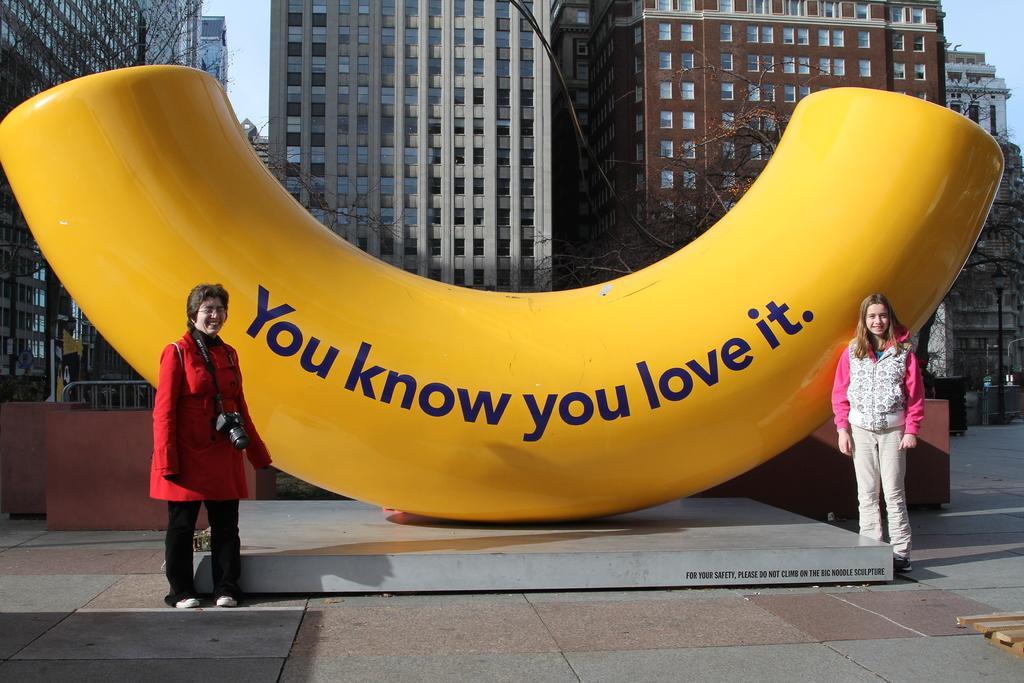In one or two sentences, can you explain what this image depicts? In this image there are two women standing near an object, on that there is some text, in the background there are trees, buildings and the sky. 